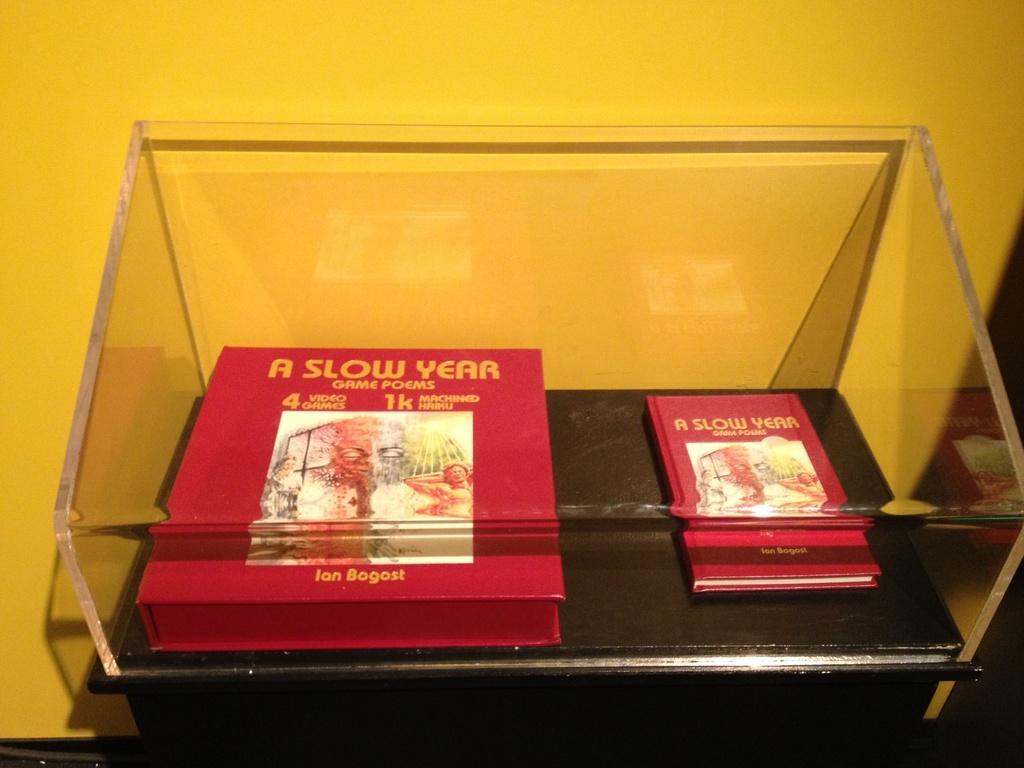How would you summarize this image in a sentence or two? In this image, we can see books are placed on a table and covered with glass object. On the books, we can see some text and figures. Background we can see the wall. Here we can see few reflections. 